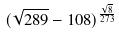Convert formula to latex. <formula><loc_0><loc_0><loc_500><loc_500>( \sqrt { 2 8 9 } - 1 0 8 ) ^ { \frac { \sqrt { 8 } } { 2 7 3 } }</formula> 